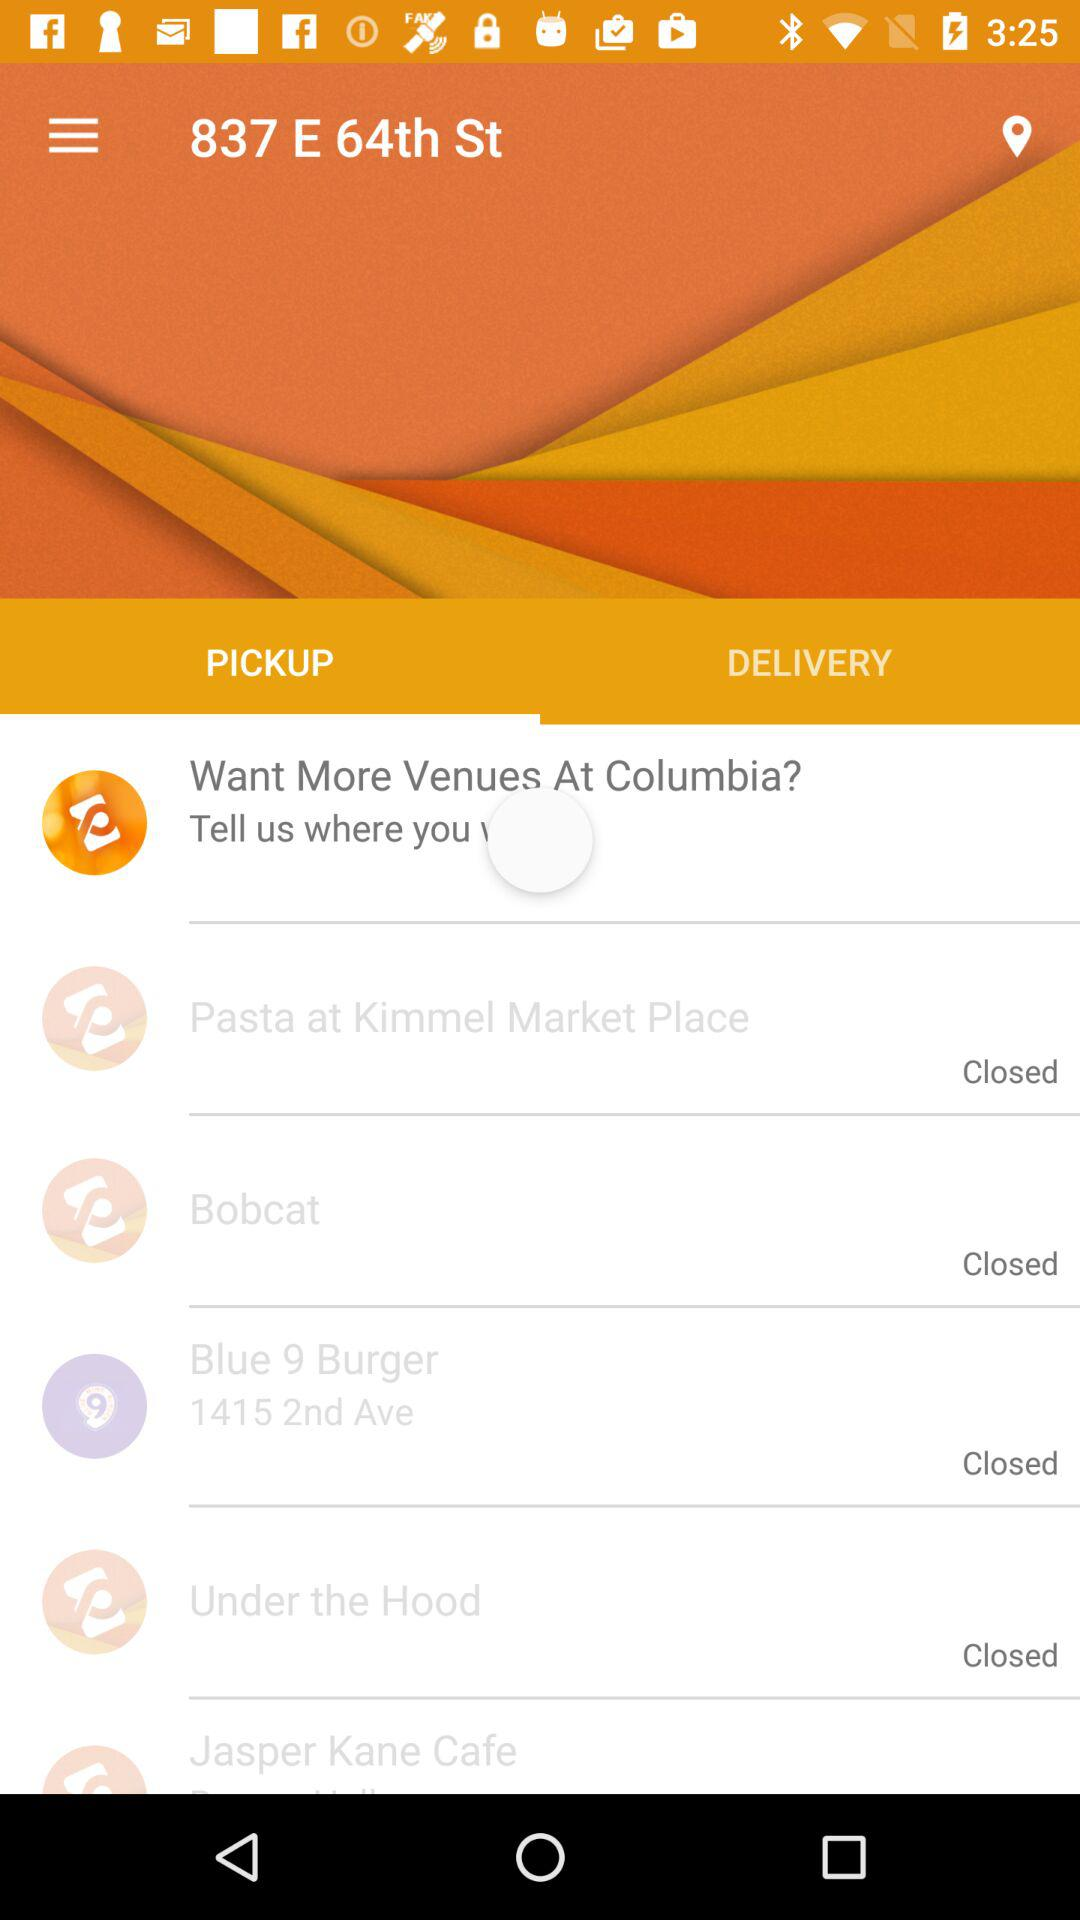What is the entered location? The entered location is 837 E 64th St. 